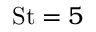Convert formula to latex. <formula><loc_0><loc_0><loc_500><loc_500>S t = 5</formula> 